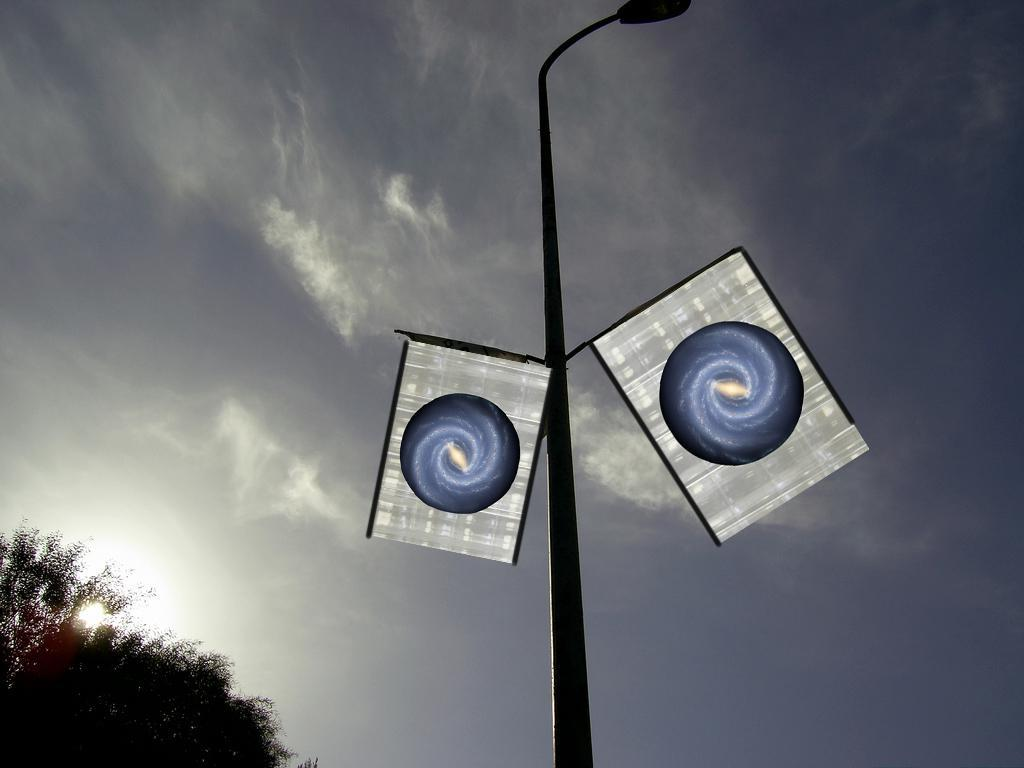What can be seen in the sky in the image? The sky is visible in the image. What is the source of light in the image? Sunlight is present in the image. What type of vegetation is visible in the bottom left of the image? Trees are visible in the bottom left of the image. What is located in the foreground of the image? There is a pole in the foreground of the image. What is attached to the pole in the image? Lights and flags are attached to the pole. How many quince are hanging from the pole in the image? There are no quince present in the image; the pole has lights and flags attached to it. 